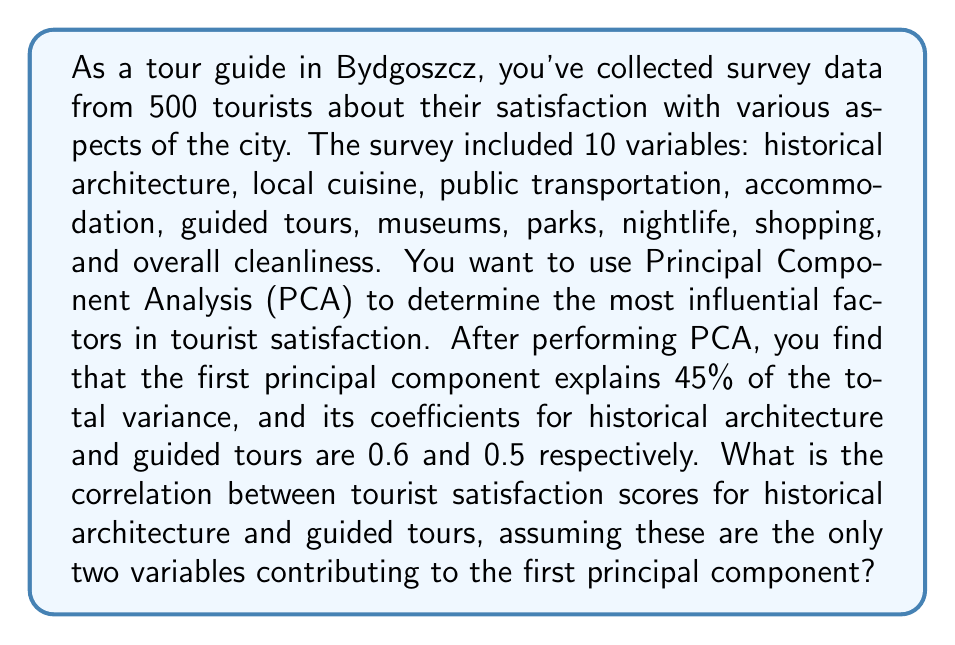Show me your answer to this math problem. To solve this problem, we need to understand the relationship between PCA coefficients and correlation in a two-variable scenario. Let's break it down step-by-step:

1) In PCA, when we have two variables that dominate the first principal component, their coefficients ($a$ and $b$) are related to their correlation ($r$) by the following equation:

   $$r = 2ab$$

   Where $a$ and $b$ are the normalized coefficients (i.e., $a^2 + b^2 = 1$).

2) In our case, we're given the raw coefficients:
   - Historical architecture: 0.6
   - Guided tours: 0.5

3) We need to normalize these coefficients. To do this, we divide each coefficient by the square root of the sum of their squares:

   $$\text{Normalization factor} = \sqrt{0.6^2 + 0.5^2} = \sqrt{0.61} \approx 0.7810$$

4) Normalized coefficients:
   $$a = \frac{0.6}{0.7810} \approx 0.7683$$
   $$b = \frac{0.5}{0.7810} \approx 0.6403$$

5) Now we can apply the formula for correlation:

   $$r = 2ab = 2(0.7683)(0.6403) \approx 0.9843$$

Therefore, the correlation between tourist satisfaction scores for historical architecture and guided tours is approximately 0.9843.

This high correlation suggests that tourists who are satisfied with the historical architecture of Bydgoszcz are also very likely to be satisfied with the guided tours, and vice versa. This makes sense for a city with rich historical architecture, where guided tours likely focus heavily on these historical aspects.
Answer: The correlation between tourist satisfaction scores for historical architecture and guided tours is approximately 0.9843. 